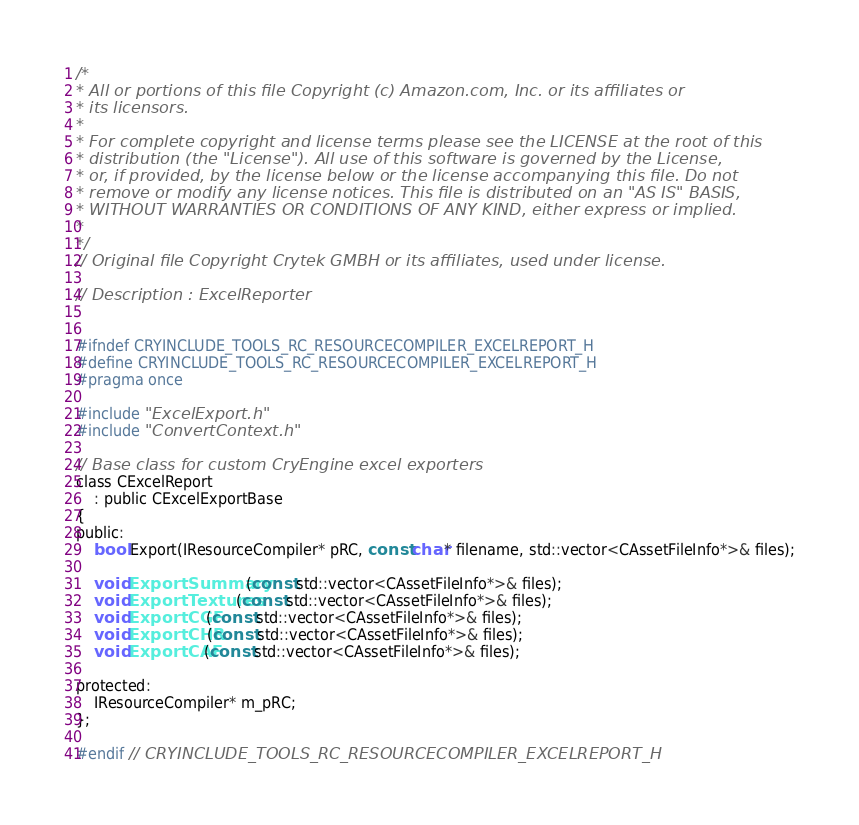Convert code to text. <code><loc_0><loc_0><loc_500><loc_500><_C_>/*
* All or portions of this file Copyright (c) Amazon.com, Inc. or its affiliates or
* its licensors.
*
* For complete copyright and license terms please see the LICENSE at the root of this
* distribution (the "License"). All use of this software is governed by the License,
* or, if provided, by the license below or the license accompanying this file. Do not
* remove or modify any license notices. This file is distributed on an "AS IS" BASIS,
* WITHOUT WARRANTIES OR CONDITIONS OF ANY KIND, either express or implied.
*
*/
// Original file Copyright Crytek GMBH or its affiliates, used under license.

// Description : ExcelReporter


#ifndef CRYINCLUDE_TOOLS_RC_RESOURCECOMPILER_EXCELREPORT_H
#define CRYINCLUDE_TOOLS_RC_RESOURCECOMPILER_EXCELREPORT_H
#pragma once

#include "ExcelExport.h"
#include "ConvertContext.h"

// Base class for custom CryEngine excel exporters
class CExcelReport
    : public CExcelExportBase
{
public:
    bool Export(IResourceCompiler* pRC, const char* filename, std::vector<CAssetFileInfo*>& files);

    void ExportSummary(const std::vector<CAssetFileInfo*>& files);
    void ExportTextures(const std::vector<CAssetFileInfo*>& files);
    void ExportCGF(const std::vector<CAssetFileInfo*>& files);
    void ExportCHR(const std::vector<CAssetFileInfo*>& files);
    void ExportCAF(const std::vector<CAssetFileInfo*>& files);

protected:
    IResourceCompiler* m_pRC;
};

#endif // CRYINCLUDE_TOOLS_RC_RESOURCECOMPILER_EXCELREPORT_H
</code> 